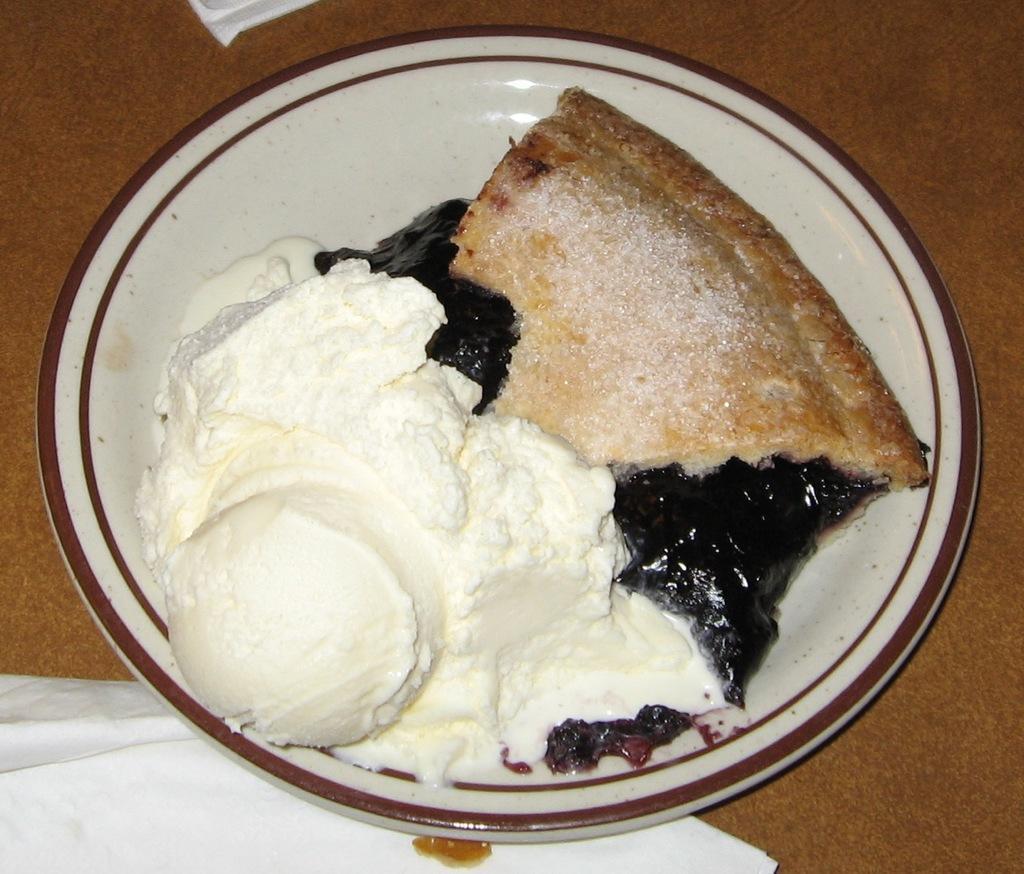Please provide a concise description of this image. In this image there is a plate which consists of some food items. This plate is placed on a wooden surface. Along with the plate there are few tissue papers. 